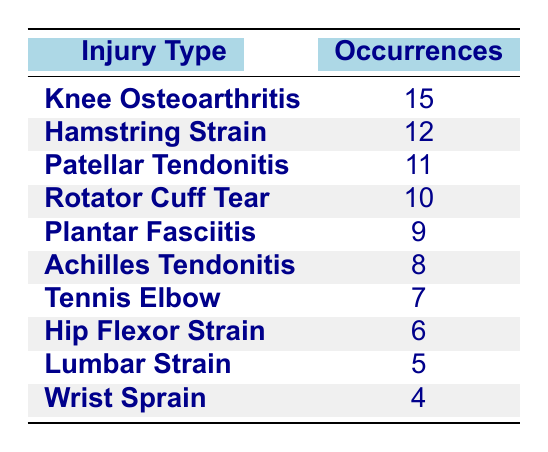What is the most common injury type among mature athletes? The most common injury type is the one with the highest occurrences in the table. By reviewing the occurrences, "Knee Osteoarthritis" has 15 occurrences, which is the highest number listed.
Answer: Knee Osteoarthritis How many occurrences of "Rotator Cuff Tear" are there? To find the number of occurrences for "Rotator Cuff Tear," we look directly at the table entry for this injury type. It shows 10 occurrences.
Answer: 10 Which injury type has the least occurrences? The least occurrences can be identified by looking for the lowest number in the occurrences column. "Wrist Sprain" has the fewest occurrences at 4.
Answer: Wrist Sprain What is the total number of occurrences for all injuries combined? To find the total, we sum up all the occurrences from the table: 15 + 12 + 11 + 10 + 9 + 8 + 7 + 6 + 5 + 4 = 87. Thus, the total number of occurrences is 87.
Answer: 87 Is there an injury type with occurrences less than 5? We check the occurrence counts in the table. Since the lowest count is 4 for "Wrist Sprain," there are no injury types below 5 occurrences. Therefore, the statement is false.
Answer: No What is the average number of occurrences per injury type? First, there are 10 different injury types listed. The total occurrences are 87 (as calculated before). The average is 87 divided by 10, which equals 8.7.
Answer: 8.7 How many injury types have occurrences greater than 10? We review the occurrences column and count the types that exceed 10. The types are "Knee Osteoarthritis," "Hamstring Strain," and "Patellar Tendonitis," totaling 3 injury types that meet this criterion.
Answer: 3 If you combined the occurrences of "Hamstring Strain" and "Achilles Tendonitis," what would be the total? Adding the occurrences of these two injury types gives us: 12 (Hamstring Strain) + 8 (Achilles Tendonitis) = 20. Thus, the combined total is 20.
Answer: 20 Which injury type occurs more often: "Lumbar Strain" or "Hip Flexor Strain"? We check the occurrences for both: "Lumbar Strain" has 5 occurrences while "Hip Flexor Strain" has 6. Since 6 is greater than 5, "Hip Flexor Strain" occurs more often.
Answer: Hip Flexor Strain 